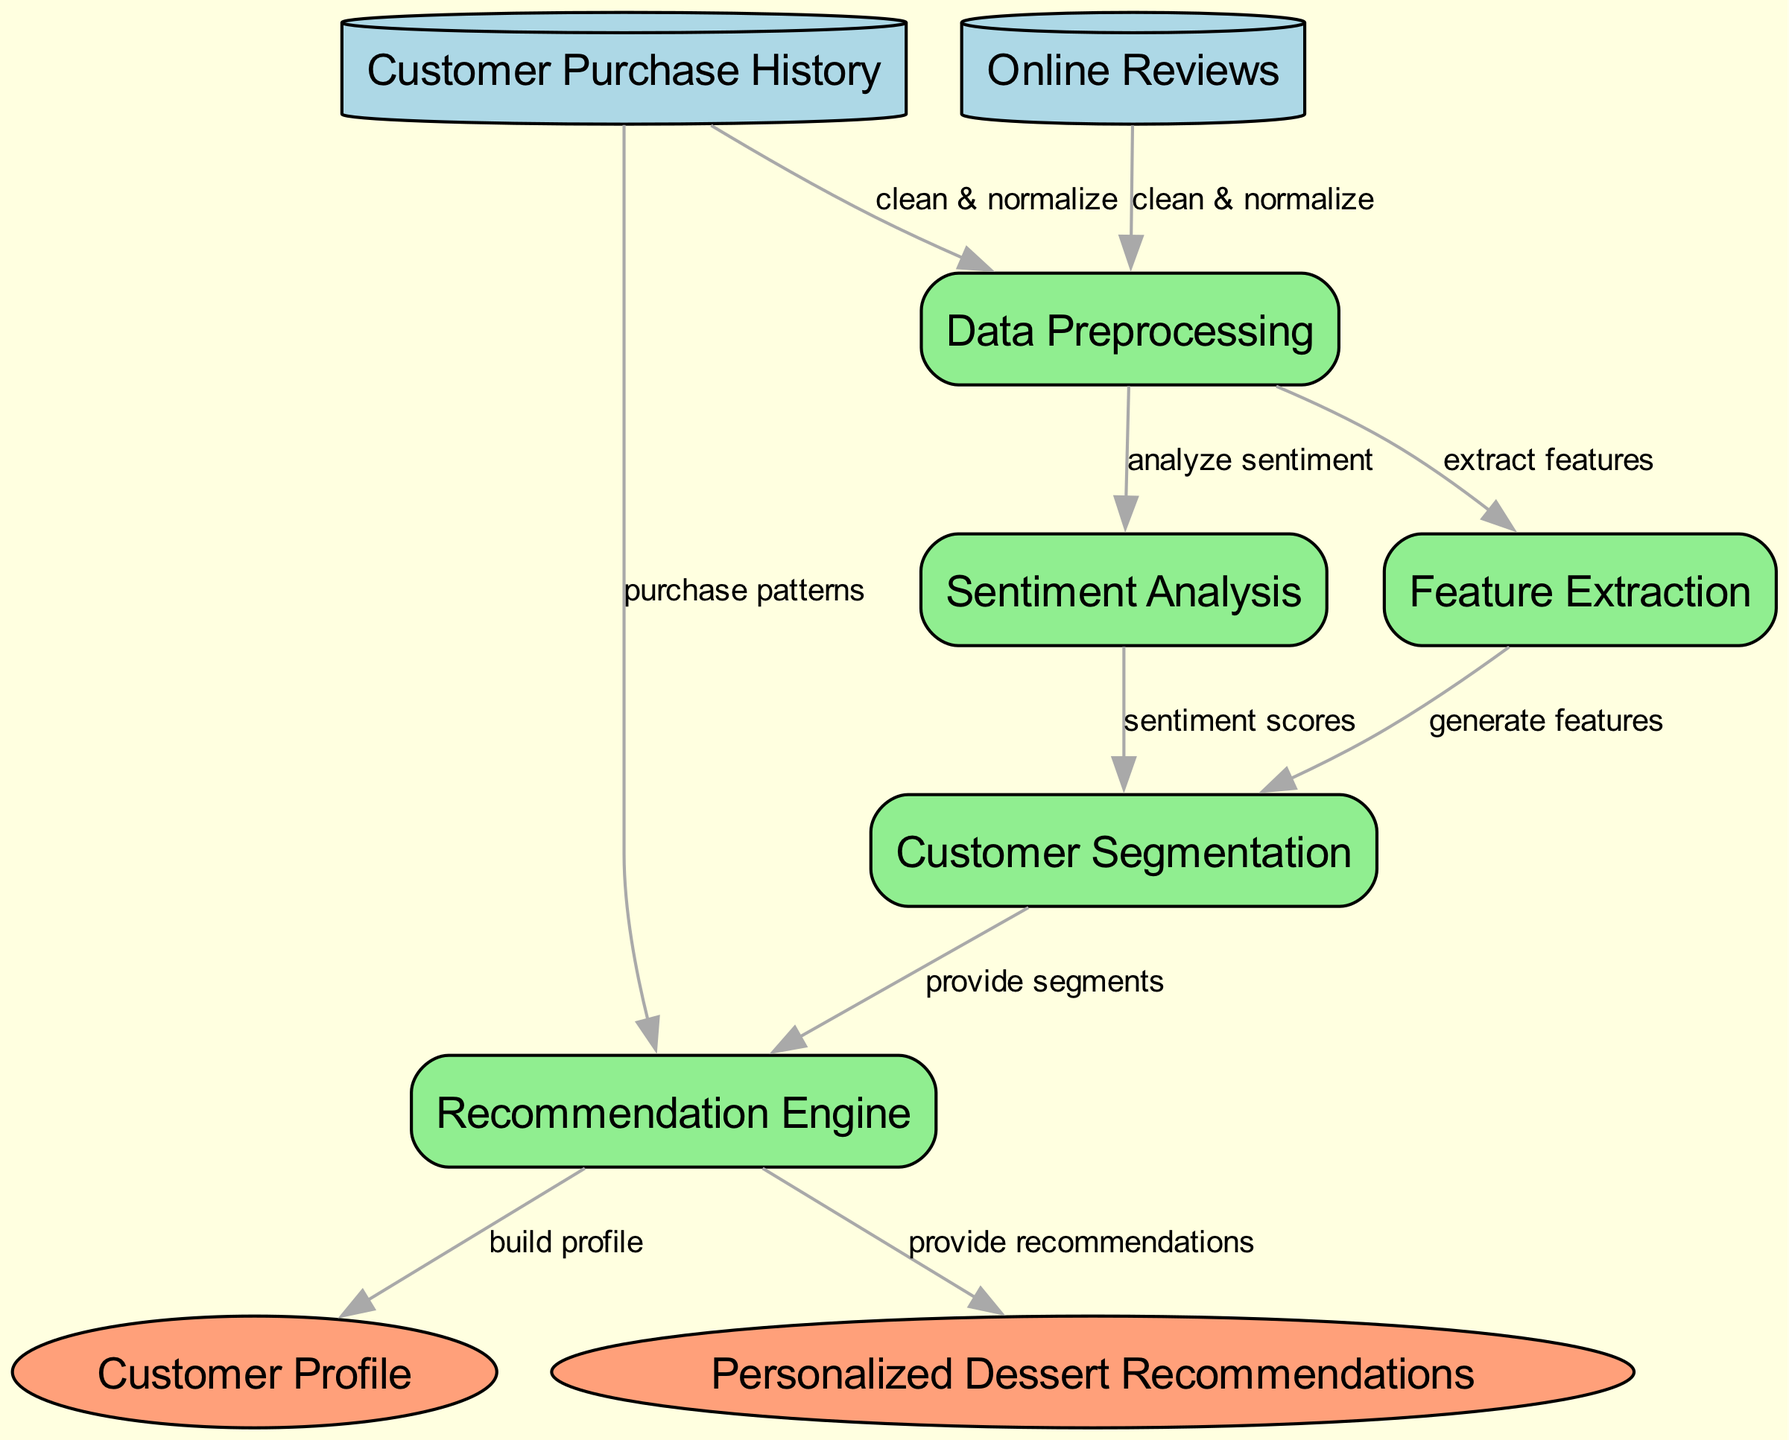What is the final output of the recommendation engine? The diagram indicates that the final output from the recommendation engine is "Personalized Dessert Recommendations." This is derived from the last edge that connects the recommendation engine to the output node representing dessert suggestions.
Answer: Personalized Dessert Recommendations How many data sources are present in the diagram? By examining the nodes in the diagram, there are two data sources: "Customer Purchase History" and "Online Reviews." Counting these nodes provides the answer.
Answer: 2 What type of process is "Customer Segmentation"? The node "Customer Segmentation" is classified as a process, which can be determined by inspecting the node type assigned in the diagram.
Answer: process Which nodes provide input to the recommendation engine? The recommendation engine receives input from two nodes: "Customer Purchase History" (providing purchase patterns) and "Customer Segmentation" (providing segments). By looking at the edges leading into the recommendation engine, both contributing nodes can be identified.
Answer: Customer Purchase History, Customer Segmentation What kind of analysis is performed on the online reviews? The diagram illustrates that "Sentiment Analysis" is applied to "Online Reviews." This relationship can be found by checking the flow from the online reviews to the corresponding process node.
Answer: Sentiment Analysis How does the "Data Preprocessing" process interact with the feature extraction process? The "Data Preprocessing" node sends output to the "Feature Extraction" process, specifically extracting features. This relationship is shown by following the edge labeled "extract features" from the data preprocessing to feature extraction node.
Answer: extract features What is the role of sentiment scores in customer segmentation? In customer segmentation, sentiment scores serve as input derived from sentiment analysis. This is shown by the edge from sentiment analysis to customer segmentation labeled "sentiment scores," indicating that this data is utilized to segment customers.
Answer: sentiment scores What connects the data sources to the data preprocessing process? The data sources "Customer Purchase History" and "Online Reviews" both connect to the "Data Preprocessing" process through edges labeled "clean & normalize," indicating that data from these sources is being prepared similarly.
Answer: clean & normalize Which node is responsible for building customer profiles? The "Recommendation Engine" is tasked with building customer profiles, as indicated by the edge labeled "build profile" that flows to the "Customer Profile" output node.
Answer: Recommendation Engine 